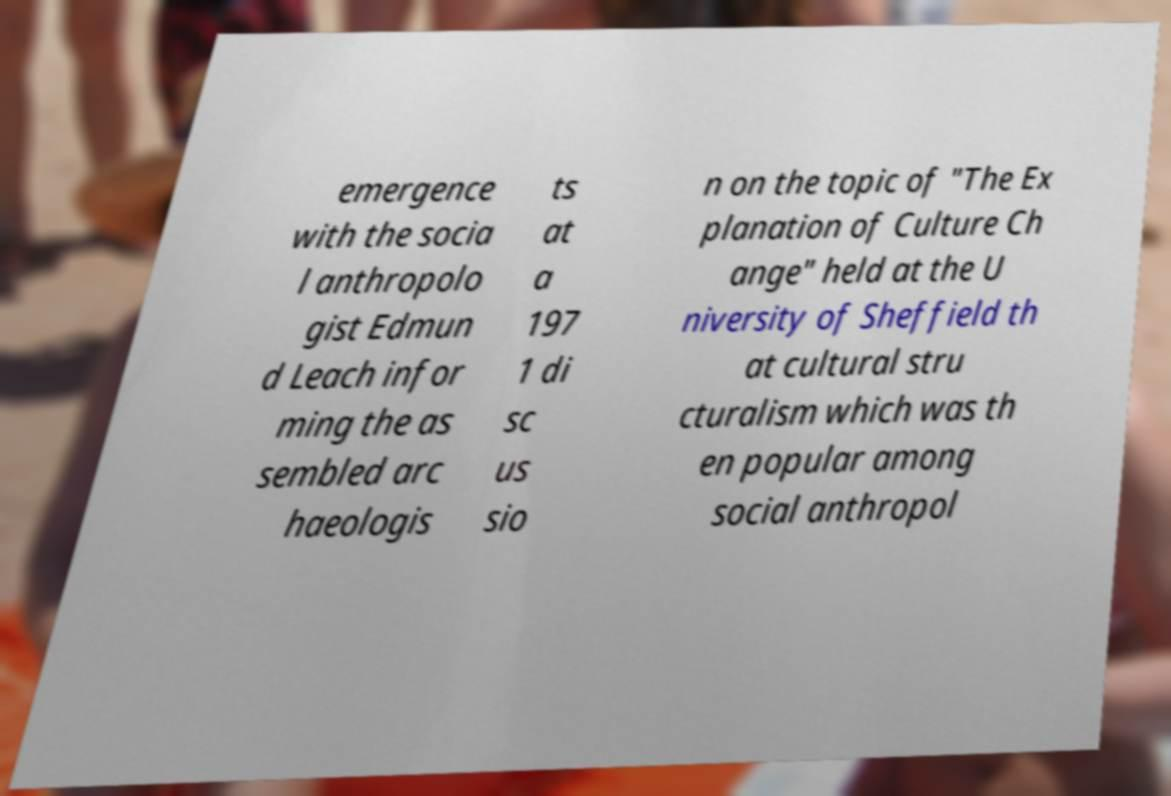Could you extract and type out the text from this image? emergence with the socia l anthropolo gist Edmun d Leach infor ming the as sembled arc haeologis ts at a 197 1 di sc us sio n on the topic of "The Ex planation of Culture Ch ange" held at the U niversity of Sheffield th at cultural stru cturalism which was th en popular among social anthropol 